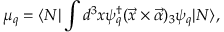<formula> <loc_0><loc_0><loc_500><loc_500>\mu _ { q } = \langle N | \int d ^ { 3 } x \psi _ { q } ^ { \dagger } ( \vec { x } \times \vec { \alpha } ) _ { 3 } \psi _ { q } | N \rangle ,</formula> 